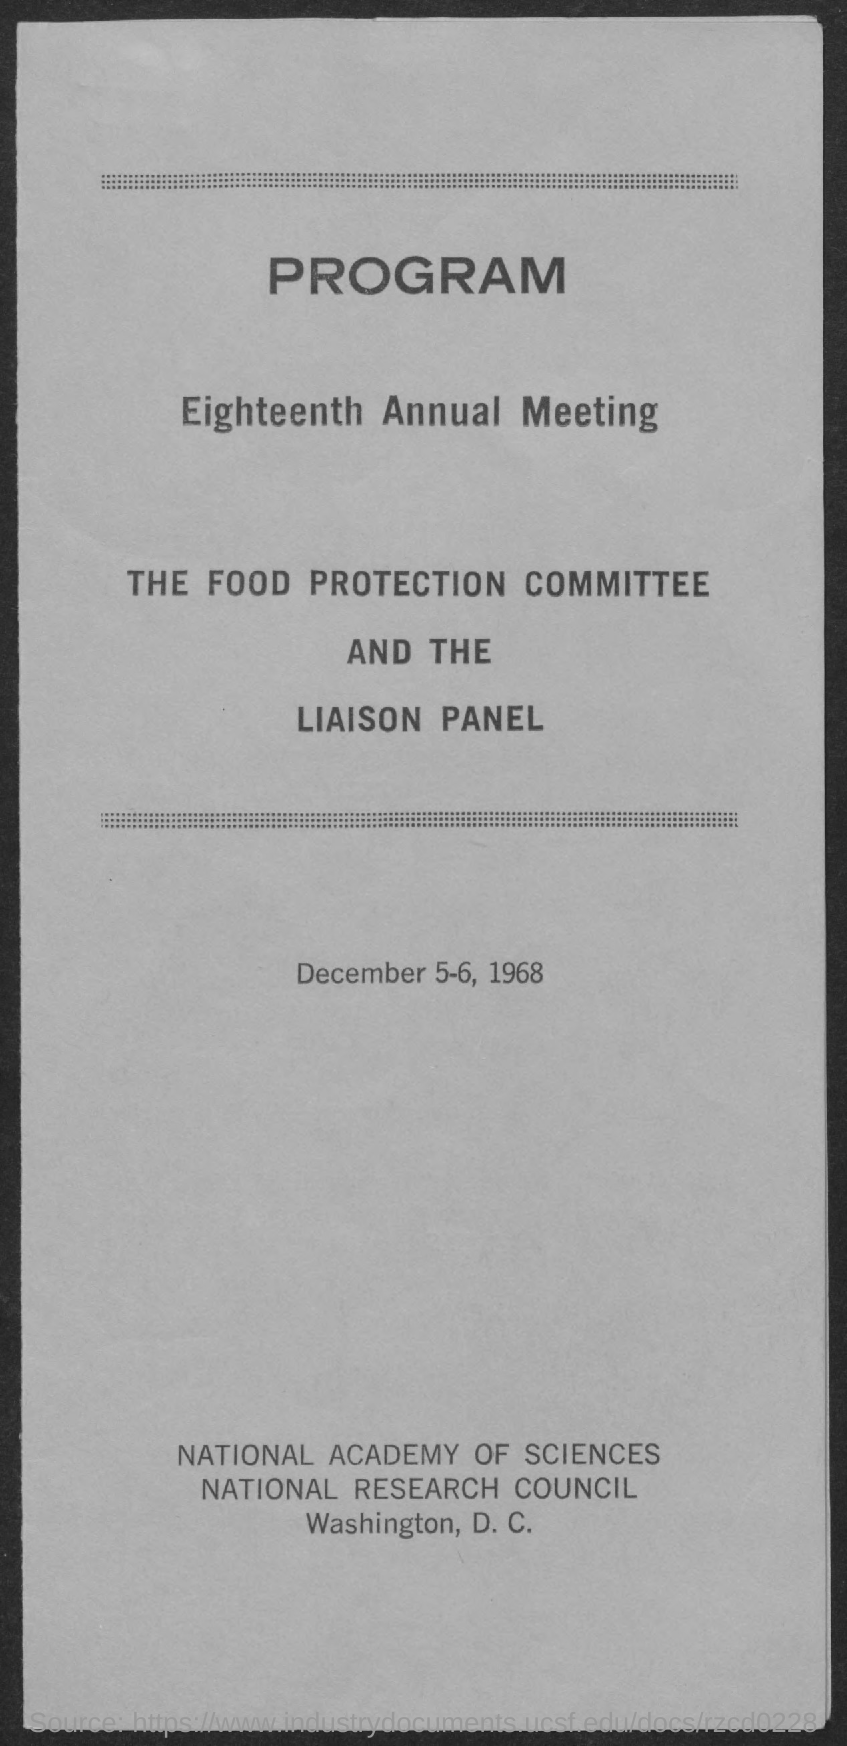Indicate a few pertinent items in this graphic. The meeting took place on December 5-6, 1968. The document's first title is "Program...". The second title in this document is the eighteenth annual meeting. 